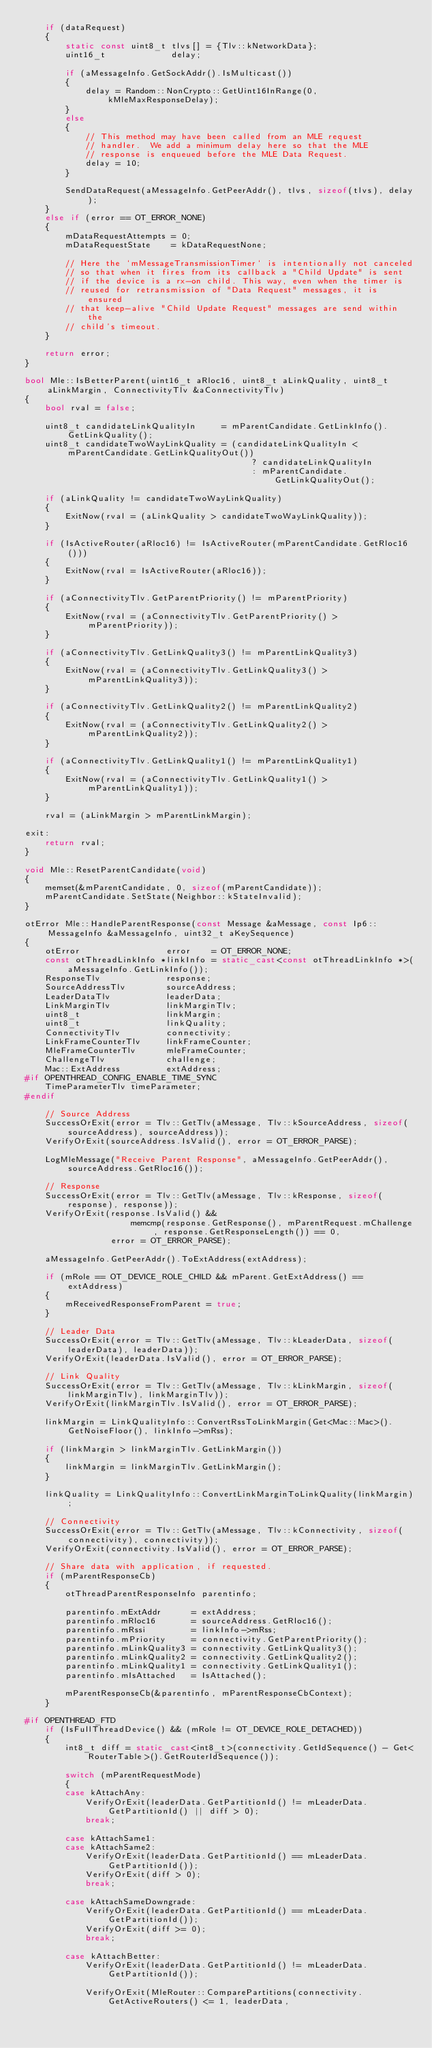Convert code to text. <code><loc_0><loc_0><loc_500><loc_500><_C++_>    if (dataRequest)
    {
        static const uint8_t tlvs[] = {Tlv::kNetworkData};
        uint16_t             delay;

        if (aMessageInfo.GetSockAddr().IsMulticast())
        {
            delay = Random::NonCrypto::GetUint16InRange(0, kMleMaxResponseDelay);
        }
        else
        {
            // This method may have been called from an MLE request
            // handler.  We add a minimum delay here so that the MLE
            // response is enqueued before the MLE Data Request.
            delay = 10;
        }

        SendDataRequest(aMessageInfo.GetPeerAddr(), tlvs, sizeof(tlvs), delay);
    }
    else if (error == OT_ERROR_NONE)
    {
        mDataRequestAttempts = 0;
        mDataRequestState    = kDataRequestNone;

        // Here the `mMessageTransmissionTimer` is intentionally not canceled
        // so that when it fires from its callback a "Child Update" is sent
        // if the device is a rx-on child. This way, even when the timer is
        // reused for retransmission of "Data Request" messages, it is ensured
        // that keep-alive "Child Update Request" messages are send within the
        // child's timeout.
    }

    return error;
}

bool Mle::IsBetterParent(uint16_t aRloc16, uint8_t aLinkQuality, uint8_t aLinkMargin, ConnectivityTlv &aConnectivityTlv)
{
    bool rval = false;

    uint8_t candidateLinkQualityIn     = mParentCandidate.GetLinkInfo().GetLinkQuality();
    uint8_t candidateTwoWayLinkQuality = (candidateLinkQualityIn < mParentCandidate.GetLinkQualityOut())
                                             ? candidateLinkQualityIn
                                             : mParentCandidate.GetLinkQualityOut();

    if (aLinkQuality != candidateTwoWayLinkQuality)
    {
        ExitNow(rval = (aLinkQuality > candidateTwoWayLinkQuality));
    }

    if (IsActiveRouter(aRloc16) != IsActiveRouter(mParentCandidate.GetRloc16()))
    {
        ExitNow(rval = IsActiveRouter(aRloc16));
    }

    if (aConnectivityTlv.GetParentPriority() != mParentPriority)
    {
        ExitNow(rval = (aConnectivityTlv.GetParentPriority() > mParentPriority));
    }

    if (aConnectivityTlv.GetLinkQuality3() != mParentLinkQuality3)
    {
        ExitNow(rval = (aConnectivityTlv.GetLinkQuality3() > mParentLinkQuality3));
    }

    if (aConnectivityTlv.GetLinkQuality2() != mParentLinkQuality2)
    {
        ExitNow(rval = (aConnectivityTlv.GetLinkQuality2() > mParentLinkQuality2));
    }

    if (aConnectivityTlv.GetLinkQuality1() != mParentLinkQuality1)
    {
        ExitNow(rval = (aConnectivityTlv.GetLinkQuality1() > mParentLinkQuality1));
    }

    rval = (aLinkMargin > mParentLinkMargin);

exit:
    return rval;
}

void Mle::ResetParentCandidate(void)
{
    memset(&mParentCandidate, 0, sizeof(mParentCandidate));
    mParentCandidate.SetState(Neighbor::kStateInvalid);
}

otError Mle::HandleParentResponse(const Message &aMessage, const Ip6::MessageInfo &aMessageInfo, uint32_t aKeySequence)
{
    otError                 error    = OT_ERROR_NONE;
    const otThreadLinkInfo *linkInfo = static_cast<const otThreadLinkInfo *>(aMessageInfo.GetLinkInfo());
    ResponseTlv             response;
    SourceAddressTlv        sourceAddress;
    LeaderDataTlv           leaderData;
    LinkMarginTlv           linkMarginTlv;
    uint8_t                 linkMargin;
    uint8_t                 linkQuality;
    ConnectivityTlv         connectivity;
    LinkFrameCounterTlv     linkFrameCounter;
    MleFrameCounterTlv      mleFrameCounter;
    ChallengeTlv            challenge;
    Mac::ExtAddress         extAddress;
#if OPENTHREAD_CONFIG_ENABLE_TIME_SYNC
    TimeParameterTlv timeParameter;
#endif

    // Source Address
    SuccessOrExit(error = Tlv::GetTlv(aMessage, Tlv::kSourceAddress, sizeof(sourceAddress), sourceAddress));
    VerifyOrExit(sourceAddress.IsValid(), error = OT_ERROR_PARSE);

    LogMleMessage("Receive Parent Response", aMessageInfo.GetPeerAddr(), sourceAddress.GetRloc16());

    // Response
    SuccessOrExit(error = Tlv::GetTlv(aMessage, Tlv::kResponse, sizeof(response), response));
    VerifyOrExit(response.IsValid() &&
                     memcmp(response.GetResponse(), mParentRequest.mChallenge, response.GetResponseLength()) == 0,
                 error = OT_ERROR_PARSE);

    aMessageInfo.GetPeerAddr().ToExtAddress(extAddress);

    if (mRole == OT_DEVICE_ROLE_CHILD && mParent.GetExtAddress() == extAddress)
    {
        mReceivedResponseFromParent = true;
    }

    // Leader Data
    SuccessOrExit(error = Tlv::GetTlv(aMessage, Tlv::kLeaderData, sizeof(leaderData), leaderData));
    VerifyOrExit(leaderData.IsValid(), error = OT_ERROR_PARSE);

    // Link Quality
    SuccessOrExit(error = Tlv::GetTlv(aMessage, Tlv::kLinkMargin, sizeof(linkMarginTlv), linkMarginTlv));
    VerifyOrExit(linkMarginTlv.IsValid(), error = OT_ERROR_PARSE);

    linkMargin = LinkQualityInfo::ConvertRssToLinkMargin(Get<Mac::Mac>().GetNoiseFloor(), linkInfo->mRss);

    if (linkMargin > linkMarginTlv.GetLinkMargin())
    {
        linkMargin = linkMarginTlv.GetLinkMargin();
    }

    linkQuality = LinkQualityInfo::ConvertLinkMarginToLinkQuality(linkMargin);

    // Connectivity
    SuccessOrExit(error = Tlv::GetTlv(aMessage, Tlv::kConnectivity, sizeof(connectivity), connectivity));
    VerifyOrExit(connectivity.IsValid(), error = OT_ERROR_PARSE);

    // Share data with application, if requested.
    if (mParentResponseCb)
    {
        otThreadParentResponseInfo parentinfo;

        parentinfo.mExtAddr      = extAddress;
        parentinfo.mRloc16       = sourceAddress.GetRloc16();
        parentinfo.mRssi         = linkInfo->mRss;
        parentinfo.mPriority     = connectivity.GetParentPriority();
        parentinfo.mLinkQuality3 = connectivity.GetLinkQuality3();
        parentinfo.mLinkQuality2 = connectivity.GetLinkQuality2();
        parentinfo.mLinkQuality1 = connectivity.GetLinkQuality1();
        parentinfo.mIsAttached   = IsAttached();

        mParentResponseCb(&parentinfo, mParentResponseCbContext);
    }

#if OPENTHREAD_FTD
    if (IsFullThreadDevice() && (mRole != OT_DEVICE_ROLE_DETACHED))
    {
        int8_t diff = static_cast<int8_t>(connectivity.GetIdSequence() - Get<RouterTable>().GetRouterIdSequence());

        switch (mParentRequestMode)
        {
        case kAttachAny:
            VerifyOrExit(leaderData.GetPartitionId() != mLeaderData.GetPartitionId() || diff > 0);
            break;

        case kAttachSame1:
        case kAttachSame2:
            VerifyOrExit(leaderData.GetPartitionId() == mLeaderData.GetPartitionId());
            VerifyOrExit(diff > 0);
            break;

        case kAttachSameDowngrade:
            VerifyOrExit(leaderData.GetPartitionId() == mLeaderData.GetPartitionId());
            VerifyOrExit(diff >= 0);
            break;

        case kAttachBetter:
            VerifyOrExit(leaderData.GetPartitionId() != mLeaderData.GetPartitionId());

            VerifyOrExit(MleRouter::ComparePartitions(connectivity.GetActiveRouters() <= 1, leaderData,</code> 